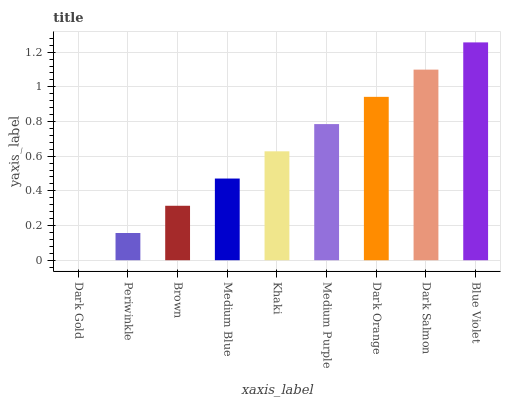Is Dark Gold the minimum?
Answer yes or no. Yes. Is Blue Violet the maximum?
Answer yes or no. Yes. Is Periwinkle the minimum?
Answer yes or no. No. Is Periwinkle the maximum?
Answer yes or no. No. Is Periwinkle greater than Dark Gold?
Answer yes or no. Yes. Is Dark Gold less than Periwinkle?
Answer yes or no. Yes. Is Dark Gold greater than Periwinkle?
Answer yes or no. No. Is Periwinkle less than Dark Gold?
Answer yes or no. No. Is Khaki the high median?
Answer yes or no. Yes. Is Khaki the low median?
Answer yes or no. Yes. Is Medium Blue the high median?
Answer yes or no. No. Is Dark Orange the low median?
Answer yes or no. No. 